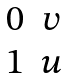<formula> <loc_0><loc_0><loc_500><loc_500>\begin{matrix} 0 & v \\ 1 & u \end{matrix}</formula> 